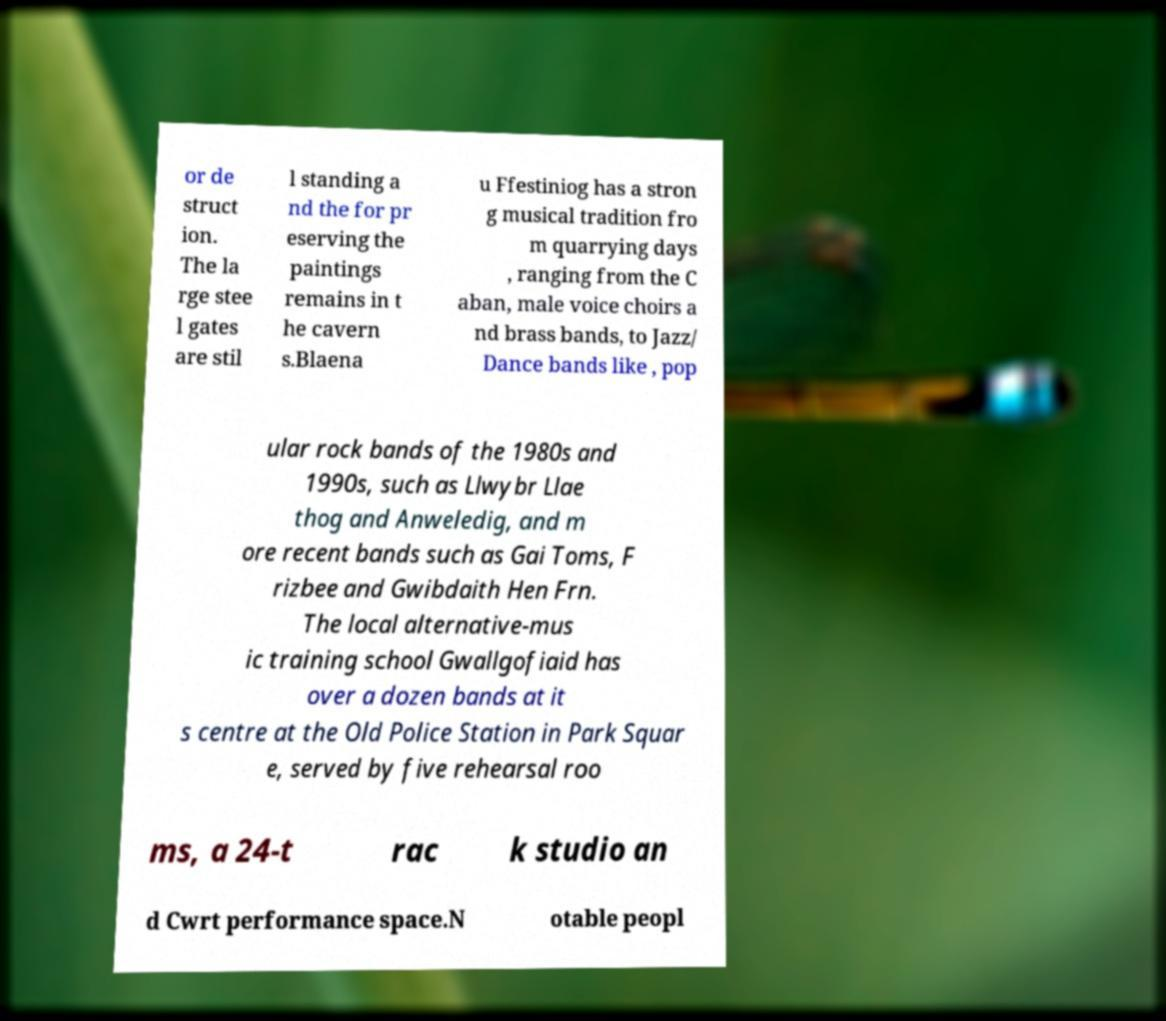There's text embedded in this image that I need extracted. Can you transcribe it verbatim? or de struct ion. The la rge stee l gates are stil l standing a nd the for pr eserving the paintings remains in t he cavern s.Blaena u Ffestiniog has a stron g musical tradition fro m quarrying days , ranging from the C aban, male voice choirs a nd brass bands, to Jazz/ Dance bands like , pop ular rock bands of the 1980s and 1990s, such as Llwybr Llae thog and Anweledig, and m ore recent bands such as Gai Toms, F rizbee and Gwibdaith Hen Frn. The local alternative-mus ic training school Gwallgofiaid has over a dozen bands at it s centre at the Old Police Station in Park Squar e, served by five rehearsal roo ms, a 24-t rac k studio an d Cwrt performance space.N otable peopl 